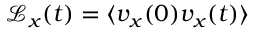Convert formula to latex. <formula><loc_0><loc_0><loc_500><loc_500>\mathcal { L } _ { x } ( t ) = \langle v _ { x } ( 0 ) v _ { x } ( t ) \rangle</formula> 